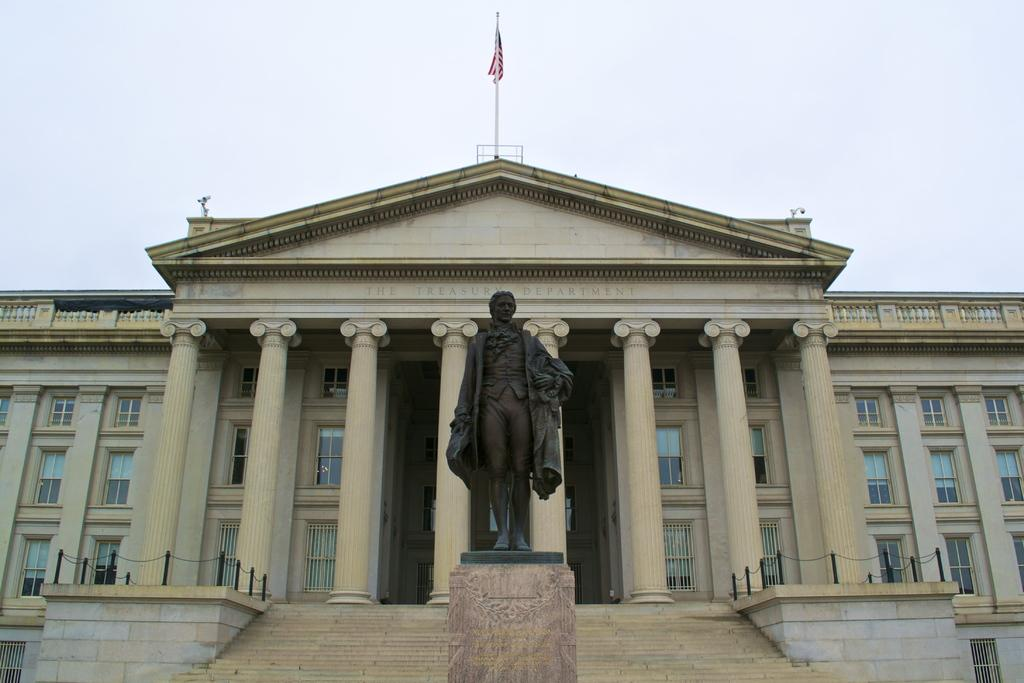What is the main subject in the middle of the image? There is a statue in the middle of the image. What structure is located behind the statue? There is a palace behind the statue. What can be seen at the top of the palace? There is a flag at the top of the palace. What is visible at the top of the image? The sky is visible at the top of the image. Where is the cow located in the image? There is no cow present in the image. What type of army is depicted in the image? There is no army depicted in the image. 